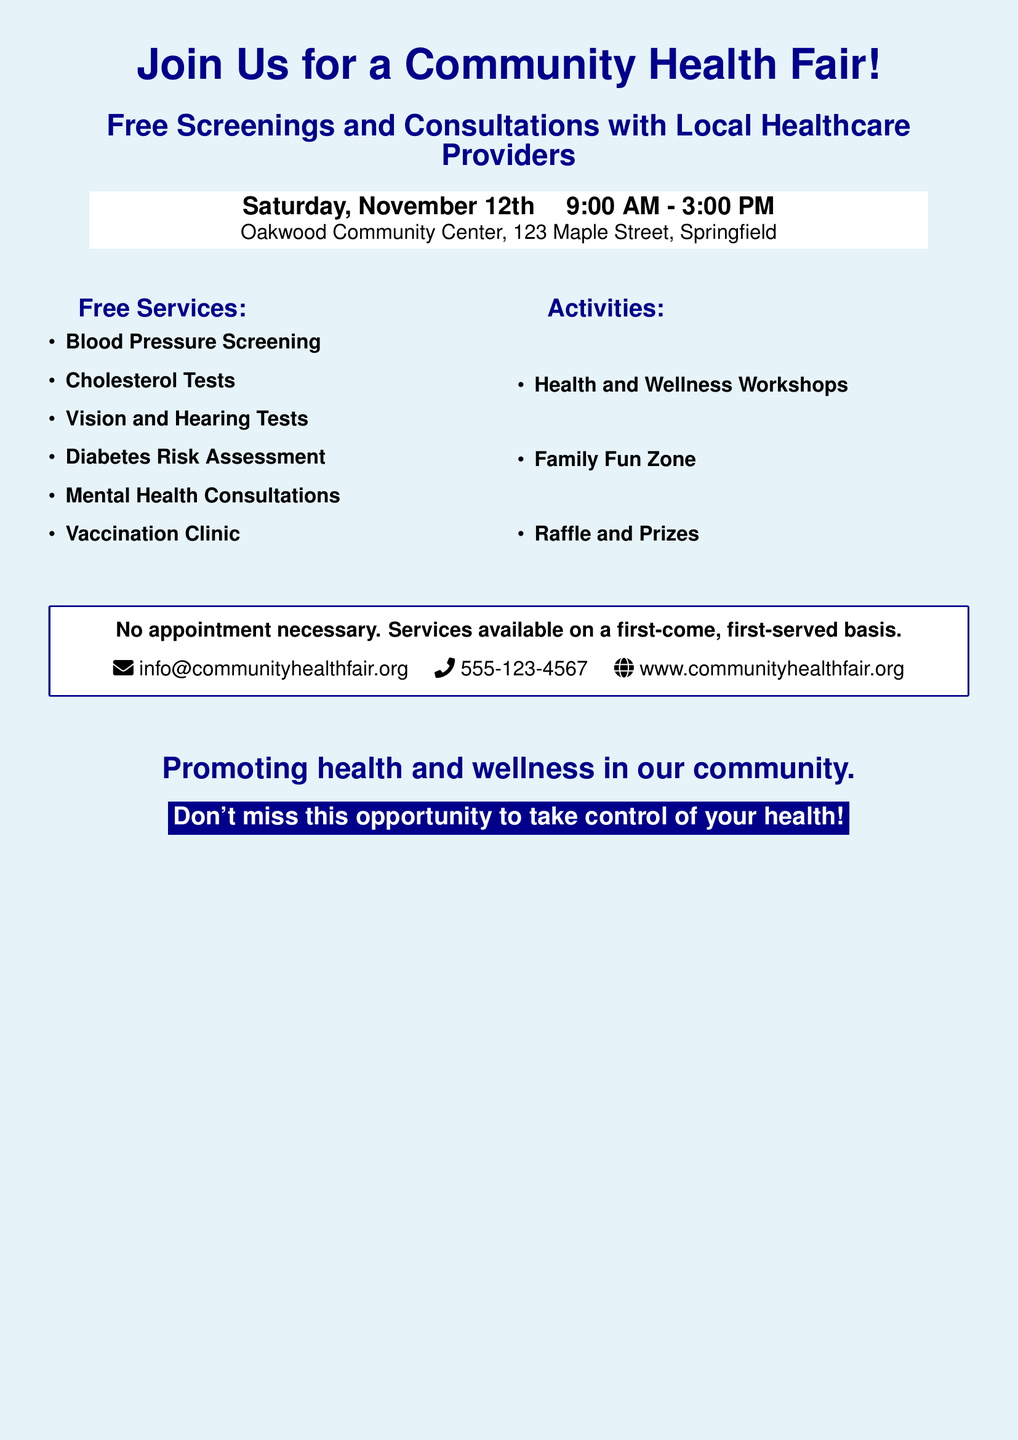What date is the Community Health Fair? The date of the Community Health Fair is specified in the document.
Answer: Saturday, November 12th What time does the event start? The starting time for the event is mentioned in the document.
Answer: 9:00 AM Where is the event taking place? The location of the event is provided within the document.
Answer: Oakwood Community Center, 123 Maple Street, Springfield What types of screenings are offered? The document lists the free services available, including screenings.
Answer: Blood Pressure Screening How long does the event last? The duration of the event can be calculated based on the start and end times given.
Answer: 6 hours Are appointments required for the services? There is information about appointment requirements in the document.
Answer: No appointment necessary What is one activity mentioned that will be at the fair? The document lists several activities, highlighting what attendees can expect.
Answer: Health and Wellness Workshops What is the email contact for more information? The document provides a contact email for inquiries regarding the health fair.
Answer: info@communityhealthfair.org What type of health service is specifically mentioned for children? The document indicates a type of service available that may be relevant for children.
Answer: Vaccination Clinic Who should attend this event? The overall aim of the advertisement suggests who would benefit from the event.
Answer: Community members 